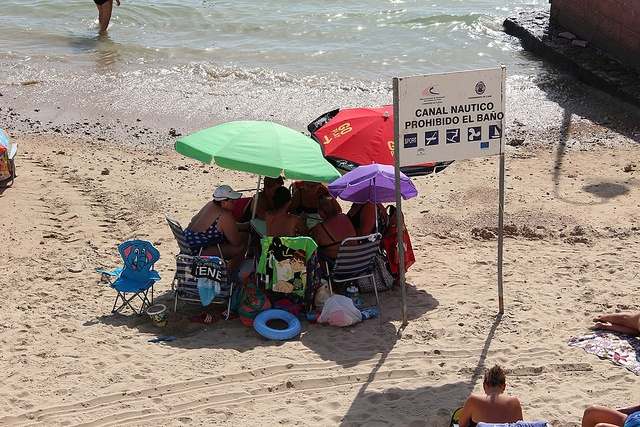Describe the objects in this image and their specific colors. I can see umbrella in darkgray, aquamarine, and green tones, umbrella in darkgray, brown, and salmon tones, chair in darkgray, black, darkgreen, and gray tones, chair in darkgray, black, gray, and blue tones, and people in darkgray, black, maroon, and gray tones in this image. 